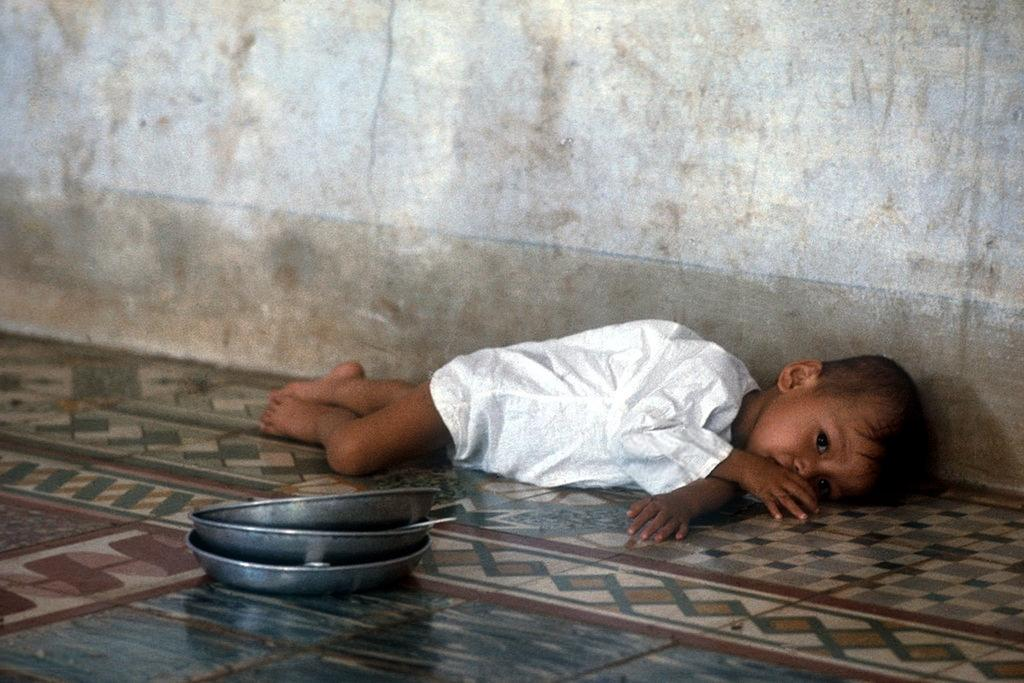What is the main subject of the image? There is a child in the image. Can you describe the child's clothing? The child is wearing a white dress. What is the child's position in the image? The child is lying on the floor. What else can be seen in the foreground of the image? There is a group of plates placed on the floor. Is the child being forced to work as a slave in the image? There is no indication in the image that the child is being forced to work as a slave. 